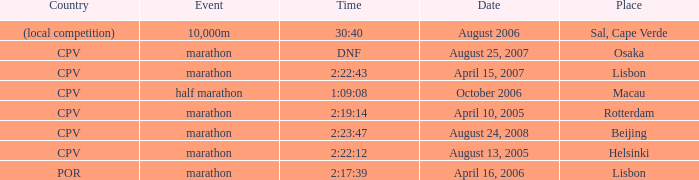In which country does the half marathon event take place? CPV. 